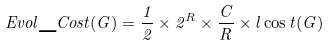Convert formula to latex. <formula><loc_0><loc_0><loc_500><loc_500>E v o l \_ C o s t ( G ) = \frac { 1 } { 2 } \times 2 ^ { R } \times \frac { C } { R } \times l \cos t ( G )</formula> 